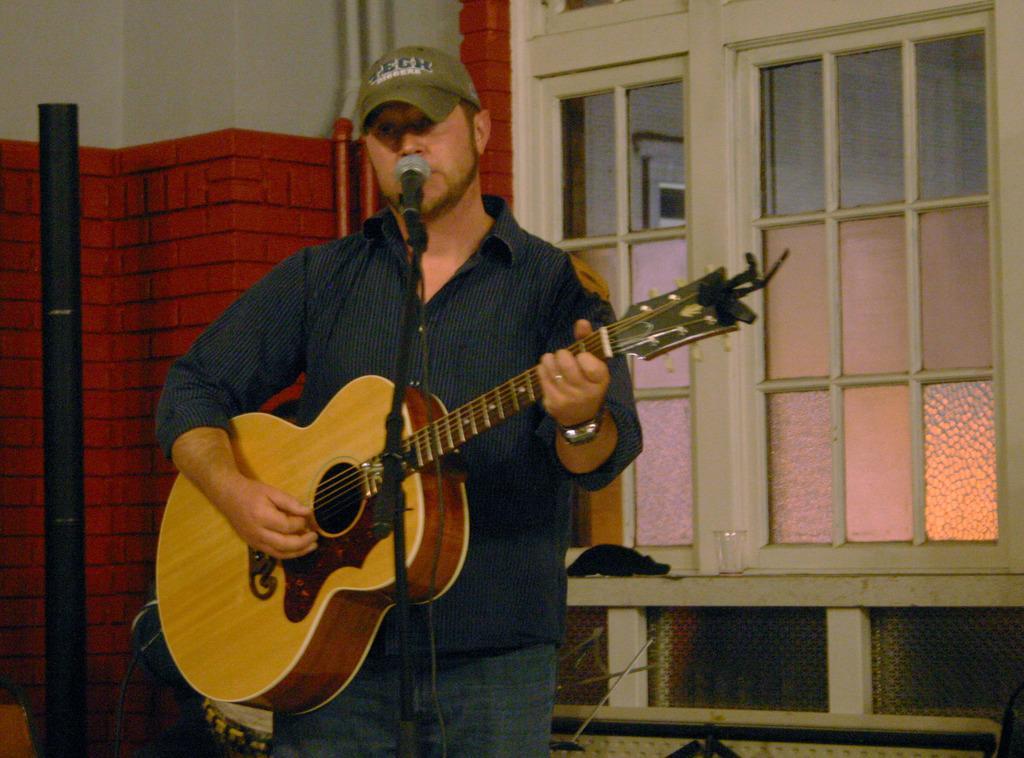Describe this image in one or two sentences. In this image i can see a man wearing a hat , a shirt and pant standing and holding a guitar, i can see a microphone in front of him. In the background i can see the wall, a pole and the window. 